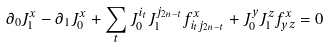<formula> <loc_0><loc_0><loc_500><loc_500>\partial _ { 0 } J _ { 1 } ^ { x } - \partial _ { 1 } J _ { 0 } ^ { x } + \sum _ { t } J _ { 0 } ^ { i _ { t } } J _ { 1 } ^ { j _ { 2 n - t } } f _ { i _ { t } j _ { 2 n - t } } ^ { x } + J _ { 0 } ^ { y } J _ { 1 } ^ { z } f _ { y z } ^ { x } = 0</formula> 